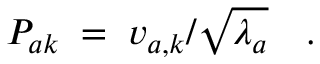Convert formula to latex. <formula><loc_0><loc_0><loc_500><loc_500>P _ { a k } \, = \, v _ { a , k } / \sqrt { \lambda _ { a } } \quad .</formula> 